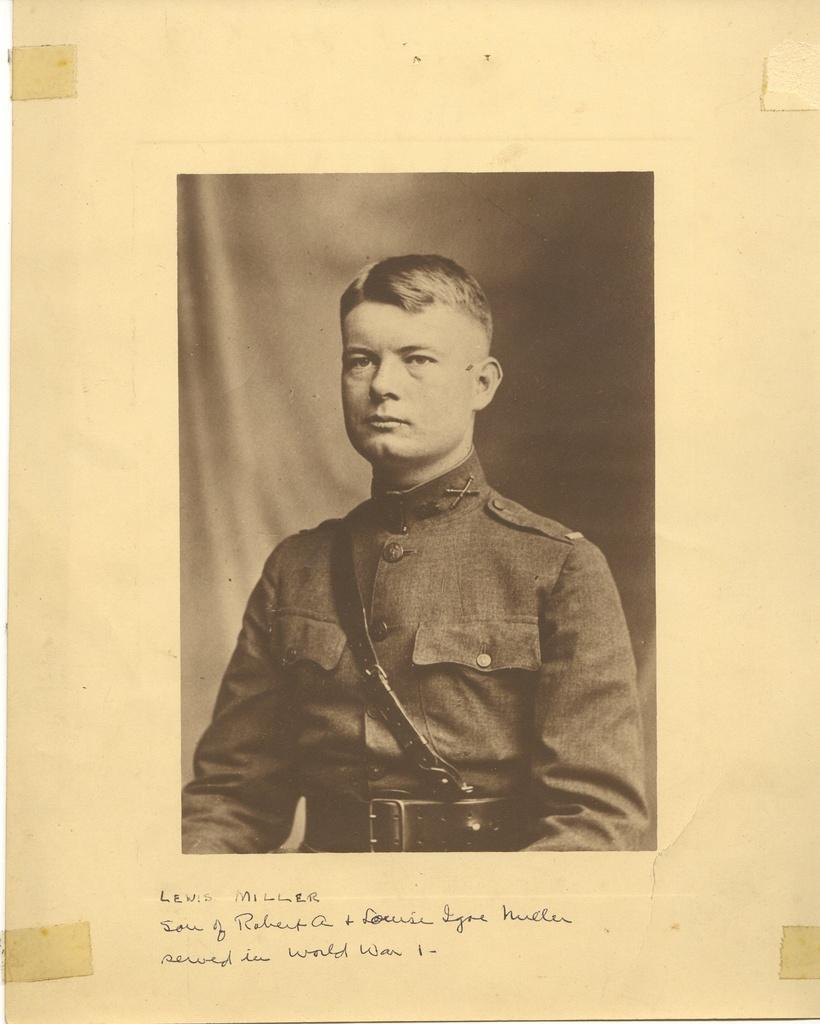How would you summarize this image in a sentence or two? In this picture we can see a photo of a man on the page and at the bottom of this photo we can see some text. 